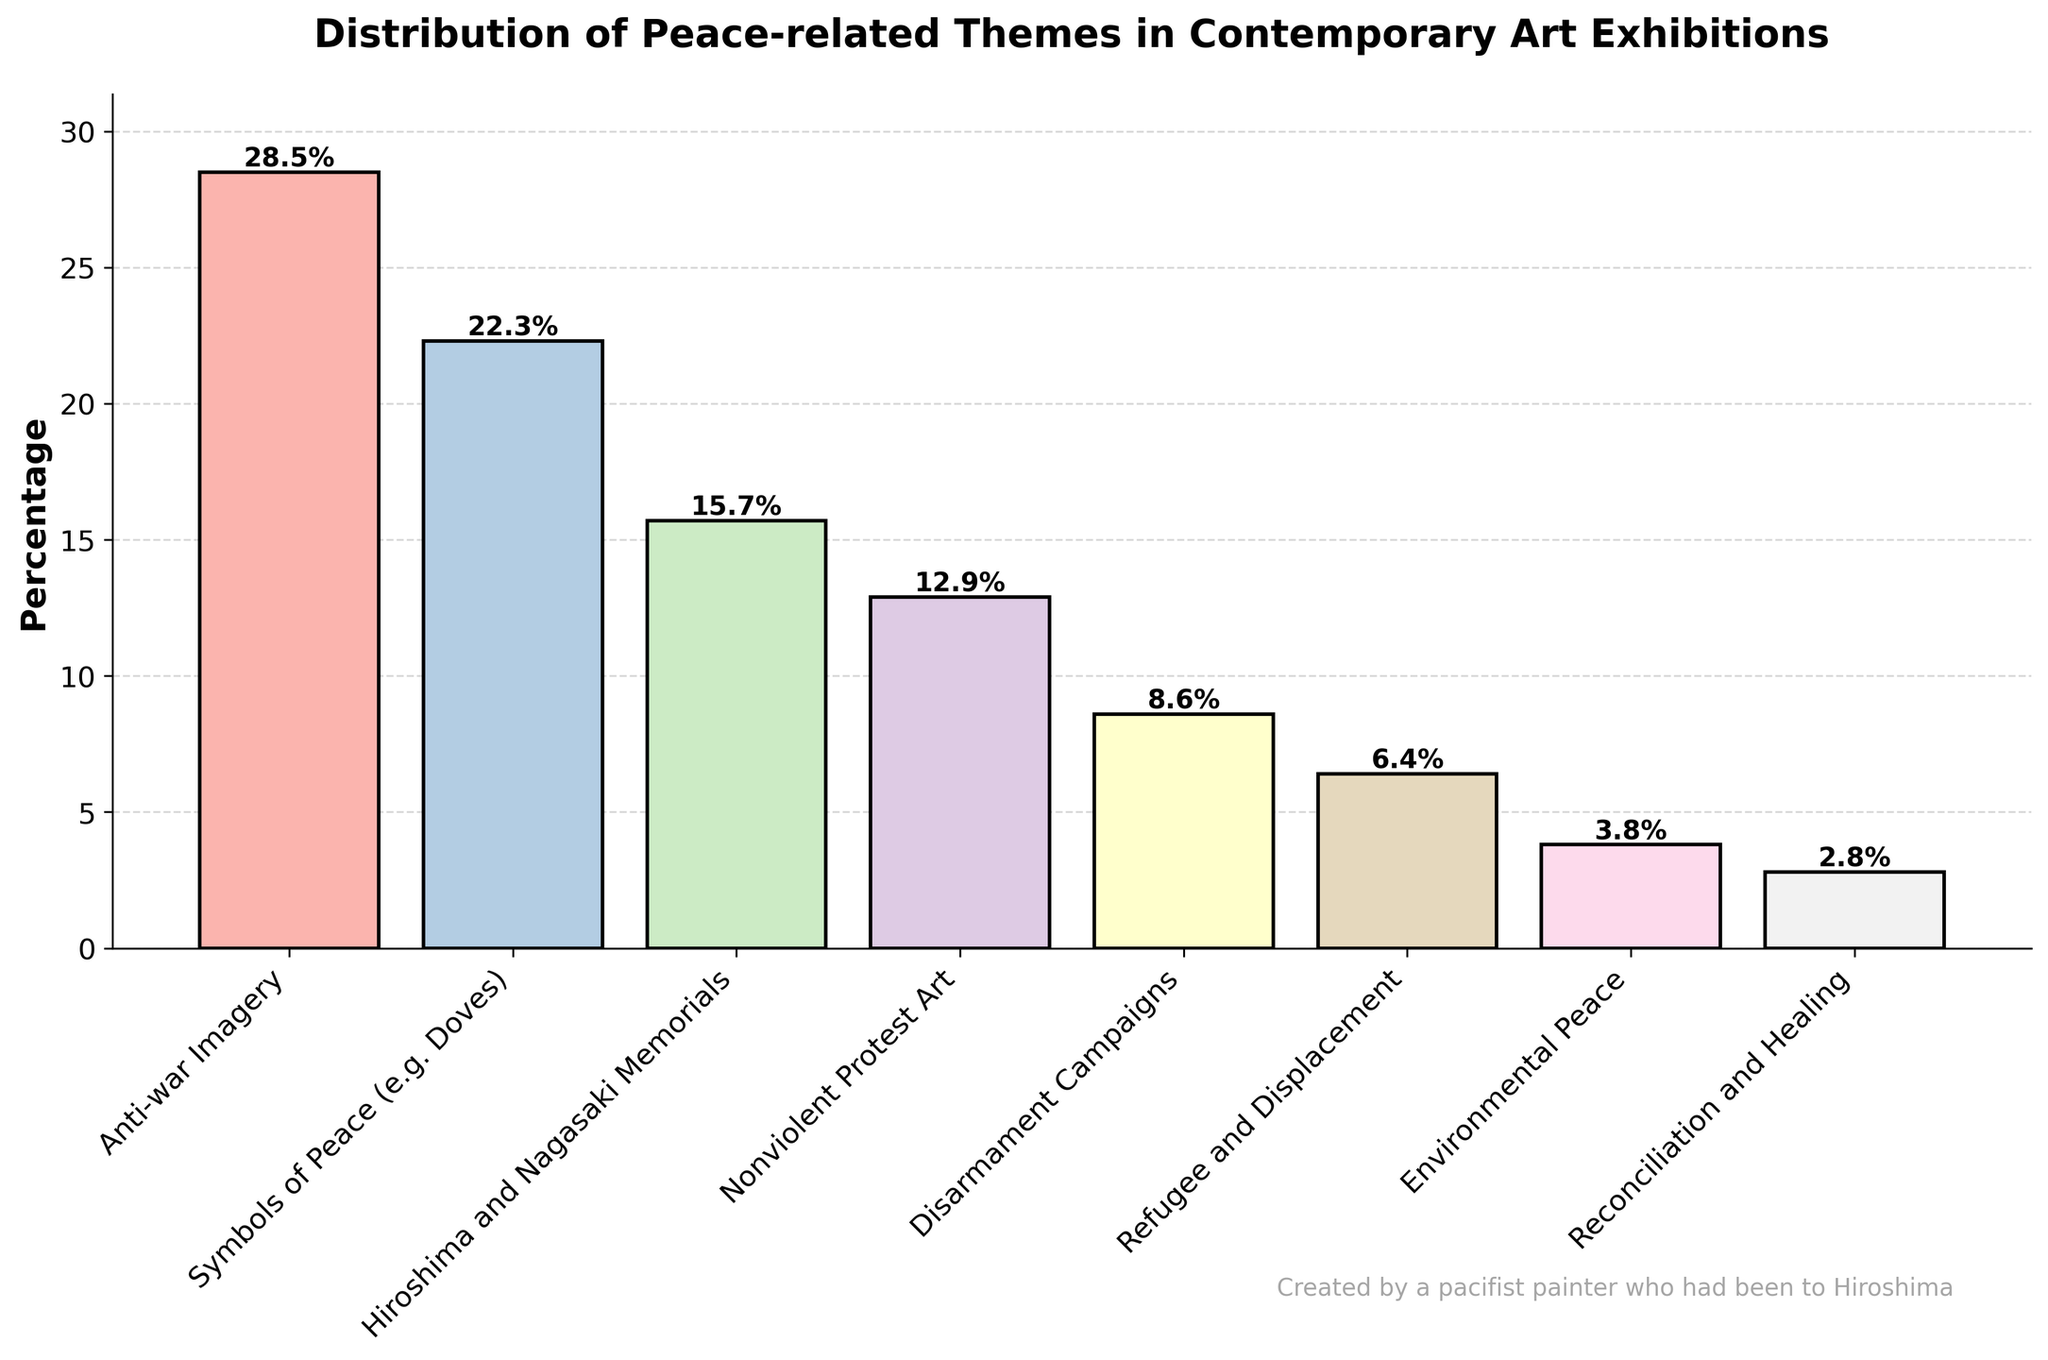What theme has the highest presence in contemporary art exhibitions? The bar chart shows that the "Anti-war Imagery" theme has the highest percentage. Anti-war Imagery has the tallest bar with 28.5%.
Answer: Anti-war Imagery What is the combined percentage of the "Anti-war Imagery" and "Symbols of Peace (e.g. Doves)" themes? The percentage for "Anti-war Imagery" is 28.5% and for "Symbols of Peace (e.g. Doves)" is 22.3%. Adding them together gives 28.5% + 22.3% = 50.8%.
Answer: 50.8% By how much does the "Anti-war Imagery" theme exceed the "Disarmament Campaigns" theme? The percentage for "Anti-war Imagery" is 28.5% and for "Disarmament Campaigns" is 8.6%. The difference is 28.5% - 8.6% = 19.9%.
Answer: 19.9% Which theme has the smallest presence in contemporary art exhibitions? The chart shows that "Reconciliation and Healing" has the lowest percentage. It is represented by the shortest bar on the chart at 2.8%.
Answer: Reconciliation and Healing What is the average percentage of all the themes depicted? Sum all percentages: 28.5 + 22.3 + 15.7 + 12.9 + 8.6 + 6.4 + 3.8 + 2.8 = 101. Adding them and dividing by 8 (number of themes): 101 / 8 = 12.625%.
Answer: 12.625% Which theme related to peace has a percentage just below 10%? The theme "Disarmament Campaigns" is the one with the percentage of 8.6%, which is just below 10%.
Answer: Disarmament Campaigns How do the percentages of "Nonviolent Protest Art" and "Refugee and Displacement" compare? "Nonviolent Protest Art" has a percentage of 12.9%, and "Refugee and Displacement" has a percentage of 6.4%. Nonviolent Protest Art has a higher percentage by 12.9% - 6.4% = 6.5%.
Answer: Nonviolent Protest Art has a higher percentage by 6.5% Are the "Environmental Peace" and "Reconciliation and Healing" themes together of similar presence to the "Nonviolent Protest Art" theme? "Environmental Peace" is 3.8% and "Reconciliation and Healing" is 2.8%, together they sum up to 3.8% + 2.8% = 6.6%. "Nonviolent Protest Art" is 12.9%, which is significantly higher than 6.6%.
Answer: No, Nonviolent Protest Art is significantly higher 